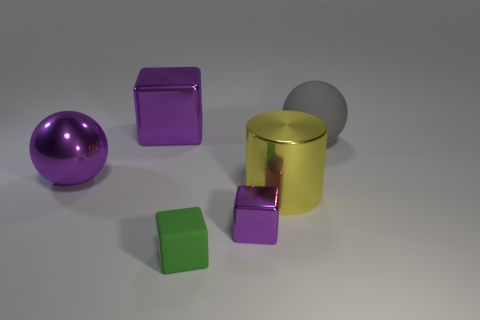Add 3 large cubes. How many objects exist? 9 Subtract all cylinders. How many objects are left? 5 Subtract all matte blocks. Subtract all small purple cubes. How many objects are left? 4 Add 3 green cubes. How many green cubes are left? 4 Add 1 large yellow matte blocks. How many large yellow matte blocks exist? 1 Subtract 0 red cubes. How many objects are left? 6 